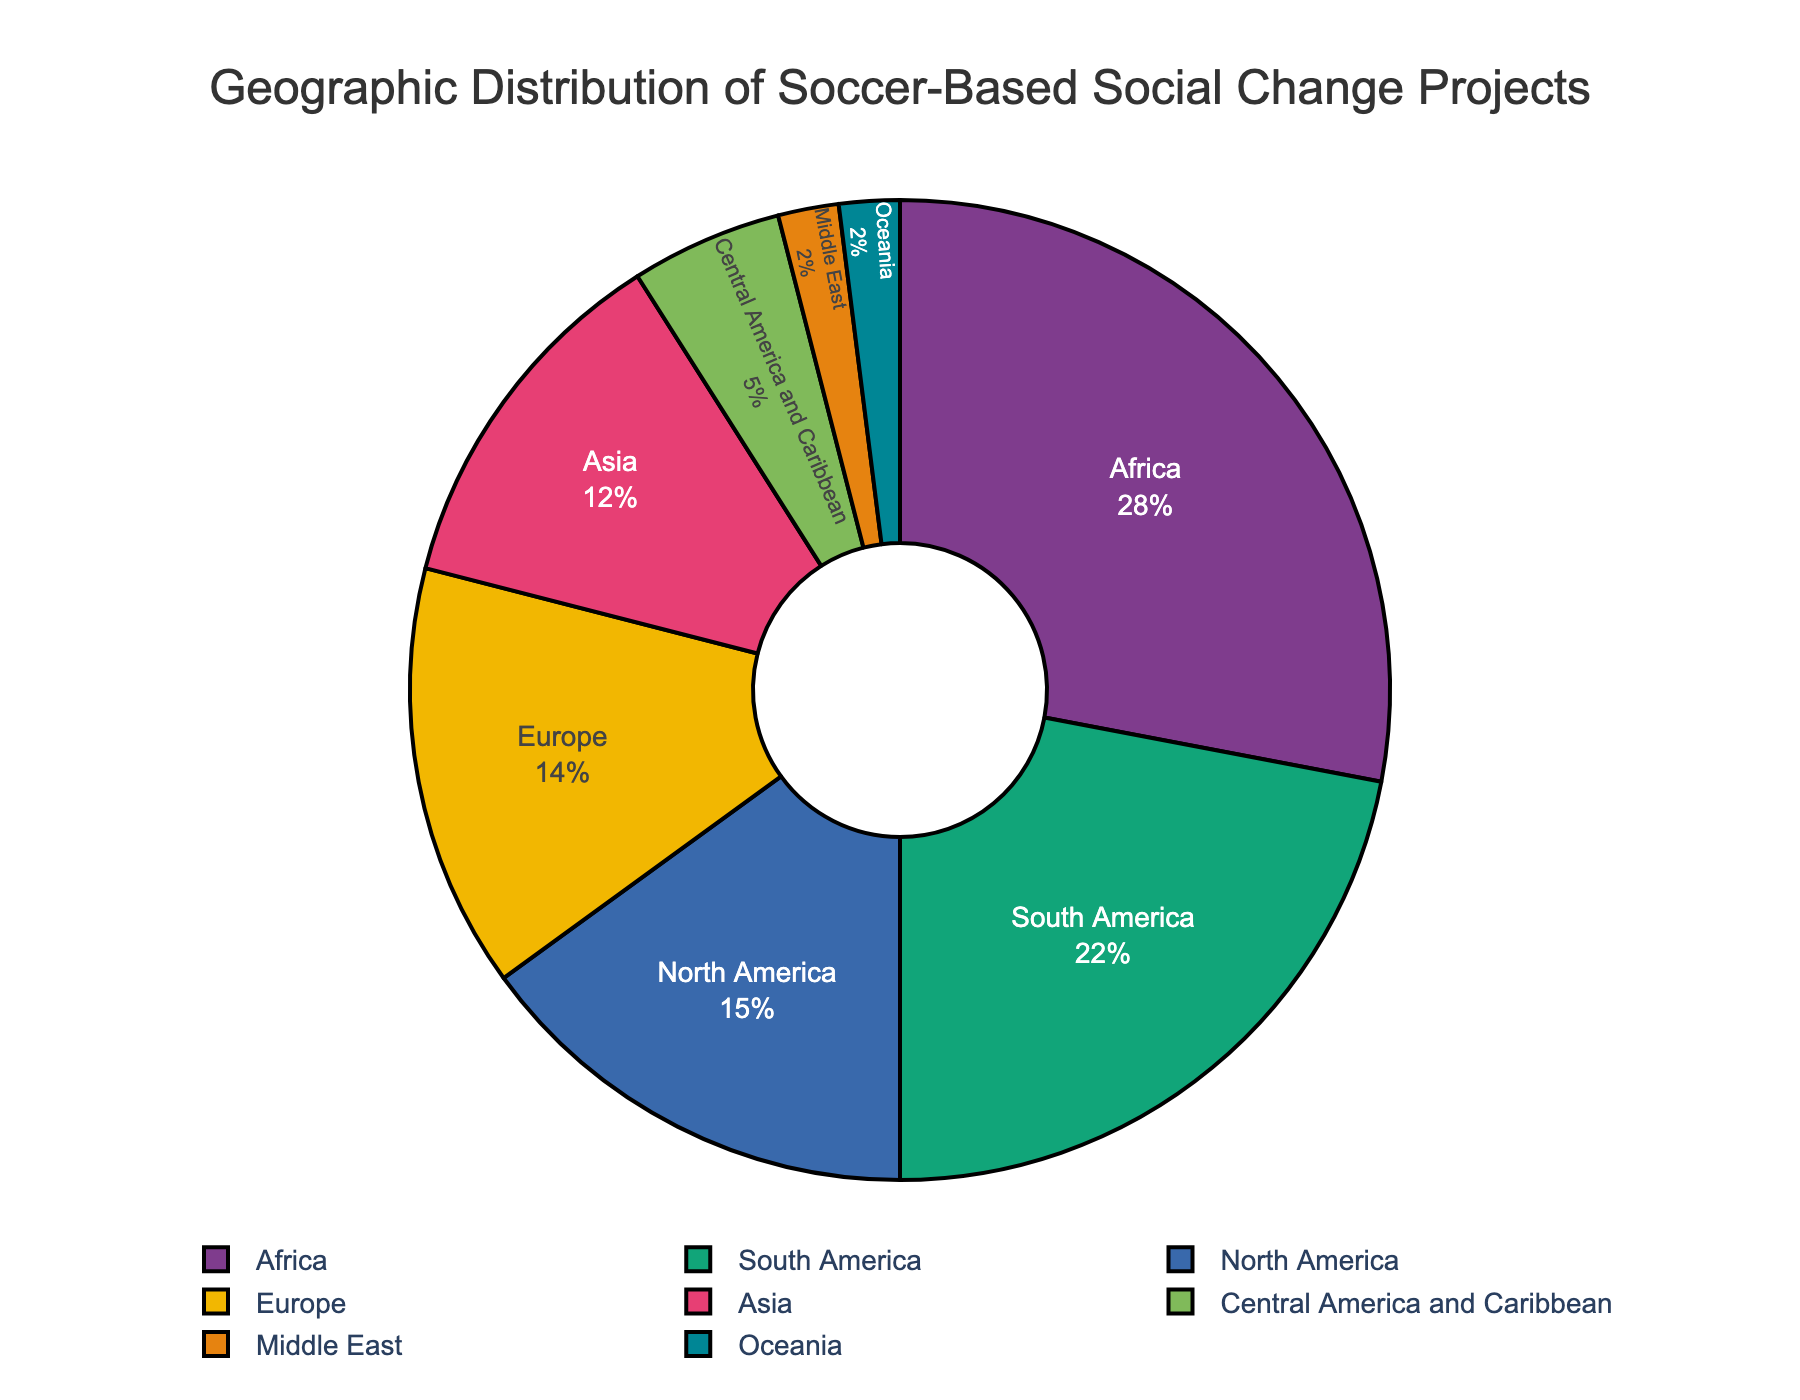What percentage of soccer-based social change projects are in Africa? The pie chart shows that Africa accounts for 28% of the total projects.
Answer: 28% Which region has the lowest percentage of soccer-based social change projects? From the chart, both the Middle East and Oceania have the lowest percentage at 2% each.
Answer: Middle East and Oceania How much higher is the percentage of projects in South America compared to Asia? The percentage of projects in South America is 22%, while in Asia it is 12%. The difference is 22% - 12% = 10%.
Answer: 10% If Central America and Caribbean's and Middle East's percentages were combined, what fraction of the total would they represent? Central America and Caribbean's percentage is 5% and Middle East's is 2%. Combined, they are 5% + 2% = 7%.
Answer: 7% Which region has a higher percentage of projects, Europe or North America, and by how much? North America has 15%, and Europe has 14%. The difference is 15% - 14% = 1%.
Answer: North America by 1% What is the total percentage of projects in the regions with less than 10%? Adding the percentages of Central America and Caribbean (5%), Middle East (2%), and Oceania (2%) gives us 5% + 2% + 2% = 9%.
Answer: 9% Is the percentage of projects in North America greater than the percentages in both Asia and Europe combined? The percentage in North America is 15%, while the combined percentage for Asia and Europe is 12% + 14% = 26%. Therefore, 15% is less than 26%.
Answer: No Which region has the second highest percentage of projects? The pie chart shows that South America, with 22%, has the second highest percentage, after Africa which has 28%.
Answer: South America What is the combined percentage of projects in Africa and South America? The percentage of projects in Africa is 28% and in South America is 22%. Combined, they account for 28% + 22% = 50%.
Answer: 50% Is Europe's percentage closer to that of Asia or North America? Europe's percentage is 14%, North America's is 15%, and Asia's is 12%. The difference between Europe and North America is 15% - 14% = 1%, and the difference between Europe and Asia is 14% - 12% = 2%. Therefore, Europe's percentage is closer to North America's.
Answer: North America 